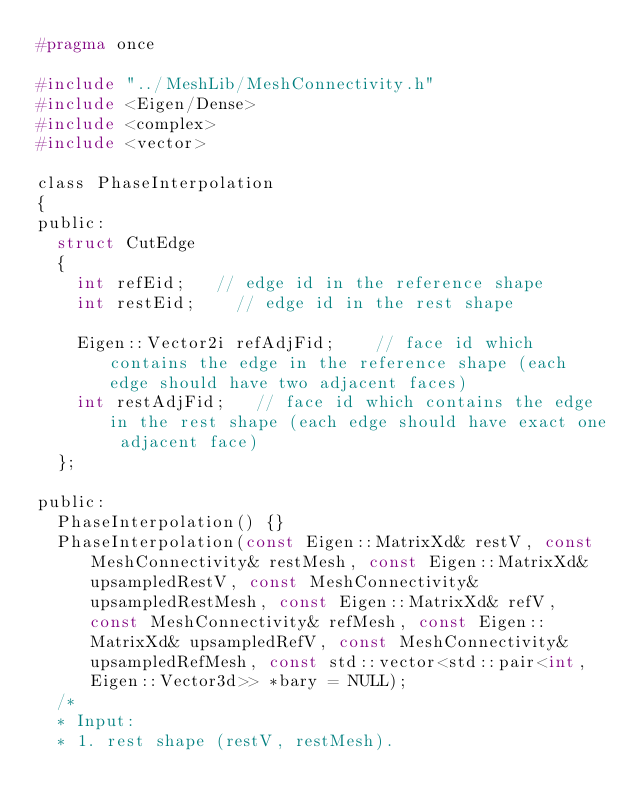Convert code to text. <code><loc_0><loc_0><loc_500><loc_500><_C_>#pragma once

#include "../MeshLib/MeshConnectivity.h"
#include <Eigen/Dense>
#include <complex>
#include <vector>

class PhaseInterpolation
{
public:
	struct CutEdge
	{
		int refEid;		// edge id in the reference shape
		int restEid;		// edge id in the rest shape

		Eigen::Vector2i refAdjFid;		// face id which contains the edge in the reference shape (each edge should have two adjacent faces)
		int restAdjFid;		// face id which contains the edge in the rest shape (each edge should have exact one adjacent face)
	};

public:
	PhaseInterpolation() {}
	PhaseInterpolation(const Eigen::MatrixXd& restV, const MeshConnectivity& restMesh, const Eigen::MatrixXd& upsampledRestV, const MeshConnectivity& upsampledRestMesh, const Eigen::MatrixXd& refV, const MeshConnectivity& refMesh, const Eigen::MatrixXd& upsampledRefV, const MeshConnectivity& upsampledRefMesh, const std::vector<std::pair<int, Eigen::Vector3d>> *bary = NULL);
	/*
	* Input:
	* 1. rest shape (restV, restMesh).</code> 